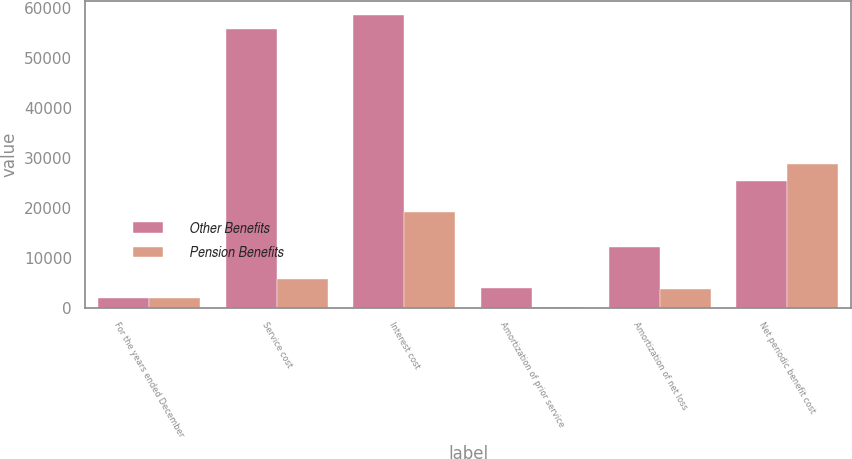<chart> <loc_0><loc_0><loc_500><loc_500><stacked_bar_chart><ecel><fcel>For the years ended December<fcel>Service cost<fcel>Interest cost<fcel>Amortization of prior service<fcel>Amortization of net loss<fcel>Net periodic benefit cost<nl><fcel>Other Benefits<fcel>2006<fcel>55759<fcel>58586<fcel>3981<fcel>12128<fcel>25336<nl><fcel>Pension Benefits<fcel>2006<fcel>5718<fcel>19083<fcel>192<fcel>3705<fcel>28698<nl></chart> 